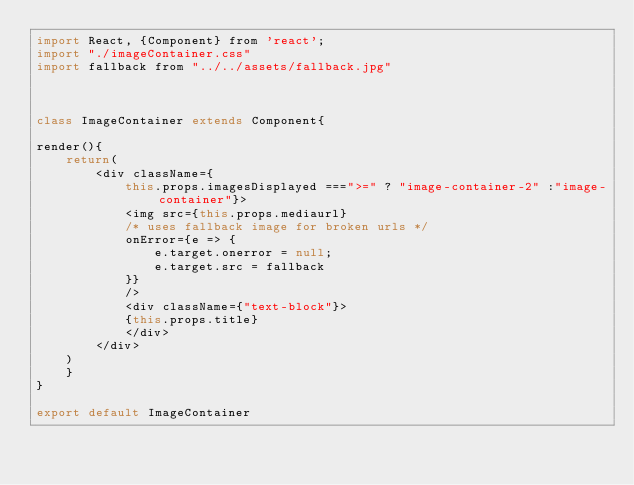<code> <loc_0><loc_0><loc_500><loc_500><_JavaScript_>import React, {Component} from 'react';
import "./imageContainer.css"
import fallback from "../../assets/fallback.jpg"



class ImageContainer extends Component{

render(){
    return(
        <div className={
            this.props.imagesDisplayed ===">=" ? "image-container-2" :"image-container"}>
            <img src={this.props.mediaurl}
            /* uses fallback image for broken urls */
            onError={e => {
                e.target.onerror = null;
                e.target.src = fallback
            }}
            />
            <div className={"text-block"}>
            {this.props.title}
            </div>
        </div>
    )
    }
}

export default ImageContainer</code> 